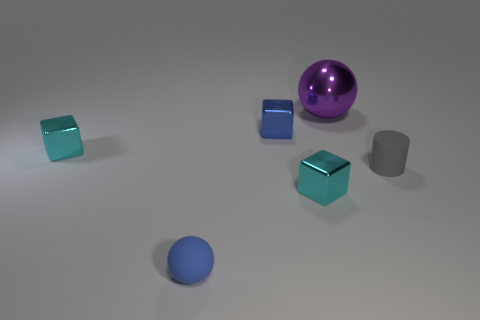What number of other objects are there of the same material as the large purple object?
Offer a very short reply. 3. Is the material of the small cyan object that is in front of the gray matte object the same as the ball that is in front of the blue metal object?
Make the answer very short. No. How many blue things are the same size as the metallic ball?
Offer a very short reply. 0. What is the shape of the object that is the same color as the rubber ball?
Offer a very short reply. Cube. What material is the ball on the left side of the purple shiny sphere?
Offer a very short reply. Rubber. How many cyan shiny objects are the same shape as the blue metal object?
Offer a terse response. 2. There is a small blue object that is the same material as the large purple sphere; what shape is it?
Provide a succinct answer. Cube. The small blue object behind the tiny matte thing that is to the left of the big metallic thing that is behind the gray thing is what shape?
Keep it short and to the point. Cube. Are there more gray objects than big cyan shiny cubes?
Your response must be concise. Yes. There is a blue thing that is the same shape as the big purple object; what material is it?
Provide a short and direct response. Rubber. 